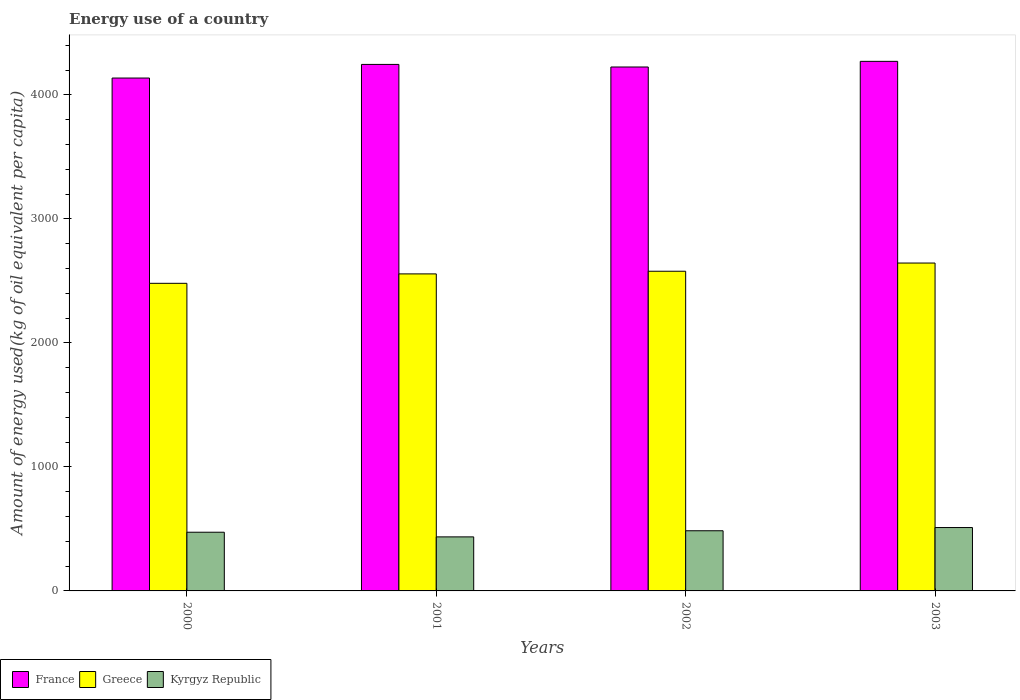In how many cases, is the number of bars for a given year not equal to the number of legend labels?
Offer a terse response. 0. What is the amount of energy used in in Kyrgyz Republic in 2000?
Provide a succinct answer. 473.38. Across all years, what is the maximum amount of energy used in in Greece?
Your answer should be very brief. 2644.61. Across all years, what is the minimum amount of energy used in in Kyrgyz Republic?
Offer a terse response. 435.88. What is the total amount of energy used in in Kyrgyz Republic in the graph?
Your answer should be compact. 1905.8. What is the difference between the amount of energy used in in Greece in 2002 and that in 2003?
Keep it short and to the point. -66.19. What is the difference between the amount of energy used in in Kyrgyz Republic in 2003 and the amount of energy used in in France in 2001?
Provide a succinct answer. -3735.27. What is the average amount of energy used in in France per year?
Your answer should be very brief. 4220.04. In the year 2002, what is the difference between the amount of energy used in in Kyrgyz Republic and amount of energy used in in France?
Give a very brief answer. -3740.44. In how many years, is the amount of energy used in in France greater than 3200 kg?
Offer a terse response. 4. What is the ratio of the amount of energy used in in Kyrgyz Republic in 2002 to that in 2003?
Your answer should be compact. 0.95. Is the amount of energy used in in Greece in 2001 less than that in 2002?
Make the answer very short. Yes. What is the difference between the highest and the second highest amount of energy used in in Kyrgyz Republic?
Offer a very short reply. 25.96. What is the difference between the highest and the lowest amount of energy used in in France?
Provide a short and direct response. 134.61. In how many years, is the amount of energy used in in Greece greater than the average amount of energy used in in Greece taken over all years?
Keep it short and to the point. 2. What does the 1st bar from the right in 2001 represents?
Provide a short and direct response. Kyrgyz Republic. How many years are there in the graph?
Give a very brief answer. 4. Where does the legend appear in the graph?
Offer a very short reply. Bottom left. What is the title of the graph?
Provide a short and direct response. Energy use of a country. What is the label or title of the Y-axis?
Your response must be concise. Amount of energy used(kg of oil equivalent per capita). What is the Amount of energy used(kg of oil equivalent per capita) of France in 2000?
Your answer should be very brief. 4136.65. What is the Amount of energy used(kg of oil equivalent per capita) in Greece in 2000?
Offer a terse response. 2481. What is the Amount of energy used(kg of oil equivalent per capita) in Kyrgyz Republic in 2000?
Your response must be concise. 473.38. What is the Amount of energy used(kg of oil equivalent per capita) of France in 2001?
Your answer should be compact. 4246.52. What is the Amount of energy used(kg of oil equivalent per capita) in Greece in 2001?
Offer a very short reply. 2557.01. What is the Amount of energy used(kg of oil equivalent per capita) of Kyrgyz Republic in 2001?
Provide a short and direct response. 435.88. What is the Amount of energy used(kg of oil equivalent per capita) of France in 2002?
Provide a succinct answer. 4225.73. What is the Amount of energy used(kg of oil equivalent per capita) in Greece in 2002?
Your answer should be compact. 2578.43. What is the Amount of energy used(kg of oil equivalent per capita) of Kyrgyz Republic in 2002?
Your answer should be compact. 485.29. What is the Amount of energy used(kg of oil equivalent per capita) of France in 2003?
Your answer should be compact. 4271.26. What is the Amount of energy used(kg of oil equivalent per capita) of Greece in 2003?
Offer a terse response. 2644.61. What is the Amount of energy used(kg of oil equivalent per capita) of Kyrgyz Republic in 2003?
Offer a terse response. 511.25. Across all years, what is the maximum Amount of energy used(kg of oil equivalent per capita) of France?
Your answer should be very brief. 4271.26. Across all years, what is the maximum Amount of energy used(kg of oil equivalent per capita) of Greece?
Make the answer very short. 2644.61. Across all years, what is the maximum Amount of energy used(kg of oil equivalent per capita) in Kyrgyz Republic?
Your answer should be compact. 511.25. Across all years, what is the minimum Amount of energy used(kg of oil equivalent per capita) of France?
Ensure brevity in your answer.  4136.65. Across all years, what is the minimum Amount of energy used(kg of oil equivalent per capita) of Greece?
Ensure brevity in your answer.  2481. Across all years, what is the minimum Amount of energy used(kg of oil equivalent per capita) of Kyrgyz Republic?
Ensure brevity in your answer.  435.88. What is the total Amount of energy used(kg of oil equivalent per capita) of France in the graph?
Ensure brevity in your answer.  1.69e+04. What is the total Amount of energy used(kg of oil equivalent per capita) in Greece in the graph?
Offer a terse response. 1.03e+04. What is the total Amount of energy used(kg of oil equivalent per capita) of Kyrgyz Republic in the graph?
Offer a very short reply. 1905.8. What is the difference between the Amount of energy used(kg of oil equivalent per capita) of France in 2000 and that in 2001?
Your answer should be very brief. -109.87. What is the difference between the Amount of energy used(kg of oil equivalent per capita) of Greece in 2000 and that in 2001?
Provide a succinct answer. -76.01. What is the difference between the Amount of energy used(kg of oil equivalent per capita) in Kyrgyz Republic in 2000 and that in 2001?
Your answer should be compact. 37.5. What is the difference between the Amount of energy used(kg of oil equivalent per capita) of France in 2000 and that in 2002?
Provide a short and direct response. -89.08. What is the difference between the Amount of energy used(kg of oil equivalent per capita) in Greece in 2000 and that in 2002?
Provide a succinct answer. -97.43. What is the difference between the Amount of energy used(kg of oil equivalent per capita) of Kyrgyz Republic in 2000 and that in 2002?
Offer a very short reply. -11.91. What is the difference between the Amount of energy used(kg of oil equivalent per capita) of France in 2000 and that in 2003?
Your response must be concise. -134.61. What is the difference between the Amount of energy used(kg of oil equivalent per capita) of Greece in 2000 and that in 2003?
Offer a very short reply. -163.61. What is the difference between the Amount of energy used(kg of oil equivalent per capita) in Kyrgyz Republic in 2000 and that in 2003?
Give a very brief answer. -37.87. What is the difference between the Amount of energy used(kg of oil equivalent per capita) of France in 2001 and that in 2002?
Provide a succinct answer. 20.79. What is the difference between the Amount of energy used(kg of oil equivalent per capita) of Greece in 2001 and that in 2002?
Keep it short and to the point. -21.41. What is the difference between the Amount of energy used(kg of oil equivalent per capita) of Kyrgyz Republic in 2001 and that in 2002?
Your response must be concise. -49.41. What is the difference between the Amount of energy used(kg of oil equivalent per capita) of France in 2001 and that in 2003?
Offer a terse response. -24.74. What is the difference between the Amount of energy used(kg of oil equivalent per capita) of Greece in 2001 and that in 2003?
Offer a terse response. -87.6. What is the difference between the Amount of energy used(kg of oil equivalent per capita) of Kyrgyz Republic in 2001 and that in 2003?
Offer a terse response. -75.38. What is the difference between the Amount of energy used(kg of oil equivalent per capita) of France in 2002 and that in 2003?
Your answer should be compact. -45.53. What is the difference between the Amount of energy used(kg of oil equivalent per capita) of Greece in 2002 and that in 2003?
Give a very brief answer. -66.19. What is the difference between the Amount of energy used(kg of oil equivalent per capita) of Kyrgyz Republic in 2002 and that in 2003?
Ensure brevity in your answer.  -25.96. What is the difference between the Amount of energy used(kg of oil equivalent per capita) in France in 2000 and the Amount of energy used(kg of oil equivalent per capita) in Greece in 2001?
Keep it short and to the point. 1579.64. What is the difference between the Amount of energy used(kg of oil equivalent per capita) in France in 2000 and the Amount of energy used(kg of oil equivalent per capita) in Kyrgyz Republic in 2001?
Provide a short and direct response. 3700.77. What is the difference between the Amount of energy used(kg of oil equivalent per capita) of Greece in 2000 and the Amount of energy used(kg of oil equivalent per capita) of Kyrgyz Republic in 2001?
Keep it short and to the point. 2045.12. What is the difference between the Amount of energy used(kg of oil equivalent per capita) in France in 2000 and the Amount of energy used(kg of oil equivalent per capita) in Greece in 2002?
Provide a succinct answer. 1558.22. What is the difference between the Amount of energy used(kg of oil equivalent per capita) of France in 2000 and the Amount of energy used(kg of oil equivalent per capita) of Kyrgyz Republic in 2002?
Your answer should be very brief. 3651.36. What is the difference between the Amount of energy used(kg of oil equivalent per capita) in Greece in 2000 and the Amount of energy used(kg of oil equivalent per capita) in Kyrgyz Republic in 2002?
Keep it short and to the point. 1995.71. What is the difference between the Amount of energy used(kg of oil equivalent per capita) of France in 2000 and the Amount of energy used(kg of oil equivalent per capita) of Greece in 2003?
Offer a terse response. 1492.04. What is the difference between the Amount of energy used(kg of oil equivalent per capita) of France in 2000 and the Amount of energy used(kg of oil equivalent per capita) of Kyrgyz Republic in 2003?
Make the answer very short. 3625.4. What is the difference between the Amount of energy used(kg of oil equivalent per capita) in Greece in 2000 and the Amount of energy used(kg of oil equivalent per capita) in Kyrgyz Republic in 2003?
Provide a succinct answer. 1969.75. What is the difference between the Amount of energy used(kg of oil equivalent per capita) of France in 2001 and the Amount of energy used(kg of oil equivalent per capita) of Greece in 2002?
Ensure brevity in your answer.  1668.09. What is the difference between the Amount of energy used(kg of oil equivalent per capita) of France in 2001 and the Amount of energy used(kg of oil equivalent per capita) of Kyrgyz Republic in 2002?
Ensure brevity in your answer.  3761.23. What is the difference between the Amount of energy used(kg of oil equivalent per capita) in Greece in 2001 and the Amount of energy used(kg of oil equivalent per capita) in Kyrgyz Republic in 2002?
Your answer should be very brief. 2071.72. What is the difference between the Amount of energy used(kg of oil equivalent per capita) of France in 2001 and the Amount of energy used(kg of oil equivalent per capita) of Greece in 2003?
Your answer should be very brief. 1601.91. What is the difference between the Amount of energy used(kg of oil equivalent per capita) in France in 2001 and the Amount of energy used(kg of oil equivalent per capita) in Kyrgyz Republic in 2003?
Your answer should be very brief. 3735.27. What is the difference between the Amount of energy used(kg of oil equivalent per capita) of Greece in 2001 and the Amount of energy used(kg of oil equivalent per capita) of Kyrgyz Republic in 2003?
Offer a very short reply. 2045.76. What is the difference between the Amount of energy used(kg of oil equivalent per capita) in France in 2002 and the Amount of energy used(kg of oil equivalent per capita) in Greece in 2003?
Keep it short and to the point. 1581.12. What is the difference between the Amount of energy used(kg of oil equivalent per capita) of France in 2002 and the Amount of energy used(kg of oil equivalent per capita) of Kyrgyz Republic in 2003?
Keep it short and to the point. 3714.48. What is the difference between the Amount of energy used(kg of oil equivalent per capita) of Greece in 2002 and the Amount of energy used(kg of oil equivalent per capita) of Kyrgyz Republic in 2003?
Provide a succinct answer. 2067.17. What is the average Amount of energy used(kg of oil equivalent per capita) of France per year?
Offer a terse response. 4220.04. What is the average Amount of energy used(kg of oil equivalent per capita) in Greece per year?
Offer a terse response. 2565.26. What is the average Amount of energy used(kg of oil equivalent per capita) in Kyrgyz Republic per year?
Ensure brevity in your answer.  476.45. In the year 2000, what is the difference between the Amount of energy used(kg of oil equivalent per capita) of France and Amount of energy used(kg of oil equivalent per capita) of Greece?
Your answer should be very brief. 1655.65. In the year 2000, what is the difference between the Amount of energy used(kg of oil equivalent per capita) of France and Amount of energy used(kg of oil equivalent per capita) of Kyrgyz Republic?
Provide a succinct answer. 3663.27. In the year 2000, what is the difference between the Amount of energy used(kg of oil equivalent per capita) of Greece and Amount of energy used(kg of oil equivalent per capita) of Kyrgyz Republic?
Provide a short and direct response. 2007.62. In the year 2001, what is the difference between the Amount of energy used(kg of oil equivalent per capita) in France and Amount of energy used(kg of oil equivalent per capita) in Greece?
Your answer should be very brief. 1689.51. In the year 2001, what is the difference between the Amount of energy used(kg of oil equivalent per capita) in France and Amount of energy used(kg of oil equivalent per capita) in Kyrgyz Republic?
Ensure brevity in your answer.  3810.64. In the year 2001, what is the difference between the Amount of energy used(kg of oil equivalent per capita) of Greece and Amount of energy used(kg of oil equivalent per capita) of Kyrgyz Republic?
Give a very brief answer. 2121.14. In the year 2002, what is the difference between the Amount of energy used(kg of oil equivalent per capita) of France and Amount of energy used(kg of oil equivalent per capita) of Greece?
Provide a succinct answer. 1647.3. In the year 2002, what is the difference between the Amount of energy used(kg of oil equivalent per capita) in France and Amount of energy used(kg of oil equivalent per capita) in Kyrgyz Republic?
Offer a terse response. 3740.44. In the year 2002, what is the difference between the Amount of energy used(kg of oil equivalent per capita) of Greece and Amount of energy used(kg of oil equivalent per capita) of Kyrgyz Republic?
Offer a terse response. 2093.14. In the year 2003, what is the difference between the Amount of energy used(kg of oil equivalent per capita) in France and Amount of energy used(kg of oil equivalent per capita) in Greece?
Make the answer very short. 1626.65. In the year 2003, what is the difference between the Amount of energy used(kg of oil equivalent per capita) of France and Amount of energy used(kg of oil equivalent per capita) of Kyrgyz Republic?
Your response must be concise. 3760.01. In the year 2003, what is the difference between the Amount of energy used(kg of oil equivalent per capita) in Greece and Amount of energy used(kg of oil equivalent per capita) in Kyrgyz Republic?
Provide a short and direct response. 2133.36. What is the ratio of the Amount of energy used(kg of oil equivalent per capita) of France in 2000 to that in 2001?
Offer a terse response. 0.97. What is the ratio of the Amount of energy used(kg of oil equivalent per capita) of Greece in 2000 to that in 2001?
Your answer should be very brief. 0.97. What is the ratio of the Amount of energy used(kg of oil equivalent per capita) of Kyrgyz Republic in 2000 to that in 2001?
Your response must be concise. 1.09. What is the ratio of the Amount of energy used(kg of oil equivalent per capita) in France in 2000 to that in 2002?
Give a very brief answer. 0.98. What is the ratio of the Amount of energy used(kg of oil equivalent per capita) in Greece in 2000 to that in 2002?
Provide a short and direct response. 0.96. What is the ratio of the Amount of energy used(kg of oil equivalent per capita) in Kyrgyz Republic in 2000 to that in 2002?
Provide a short and direct response. 0.98. What is the ratio of the Amount of energy used(kg of oil equivalent per capita) in France in 2000 to that in 2003?
Offer a very short reply. 0.97. What is the ratio of the Amount of energy used(kg of oil equivalent per capita) in Greece in 2000 to that in 2003?
Offer a very short reply. 0.94. What is the ratio of the Amount of energy used(kg of oil equivalent per capita) in Kyrgyz Republic in 2000 to that in 2003?
Make the answer very short. 0.93. What is the ratio of the Amount of energy used(kg of oil equivalent per capita) in France in 2001 to that in 2002?
Your response must be concise. 1. What is the ratio of the Amount of energy used(kg of oil equivalent per capita) of Kyrgyz Republic in 2001 to that in 2002?
Provide a succinct answer. 0.9. What is the ratio of the Amount of energy used(kg of oil equivalent per capita) of France in 2001 to that in 2003?
Your response must be concise. 0.99. What is the ratio of the Amount of energy used(kg of oil equivalent per capita) in Greece in 2001 to that in 2003?
Provide a succinct answer. 0.97. What is the ratio of the Amount of energy used(kg of oil equivalent per capita) in Kyrgyz Republic in 2001 to that in 2003?
Ensure brevity in your answer.  0.85. What is the ratio of the Amount of energy used(kg of oil equivalent per capita) of France in 2002 to that in 2003?
Keep it short and to the point. 0.99. What is the ratio of the Amount of energy used(kg of oil equivalent per capita) of Greece in 2002 to that in 2003?
Make the answer very short. 0.97. What is the ratio of the Amount of energy used(kg of oil equivalent per capita) in Kyrgyz Republic in 2002 to that in 2003?
Give a very brief answer. 0.95. What is the difference between the highest and the second highest Amount of energy used(kg of oil equivalent per capita) in France?
Your answer should be very brief. 24.74. What is the difference between the highest and the second highest Amount of energy used(kg of oil equivalent per capita) of Greece?
Keep it short and to the point. 66.19. What is the difference between the highest and the second highest Amount of energy used(kg of oil equivalent per capita) in Kyrgyz Republic?
Your answer should be compact. 25.96. What is the difference between the highest and the lowest Amount of energy used(kg of oil equivalent per capita) in France?
Offer a very short reply. 134.61. What is the difference between the highest and the lowest Amount of energy used(kg of oil equivalent per capita) of Greece?
Your answer should be very brief. 163.61. What is the difference between the highest and the lowest Amount of energy used(kg of oil equivalent per capita) in Kyrgyz Republic?
Your answer should be very brief. 75.38. 